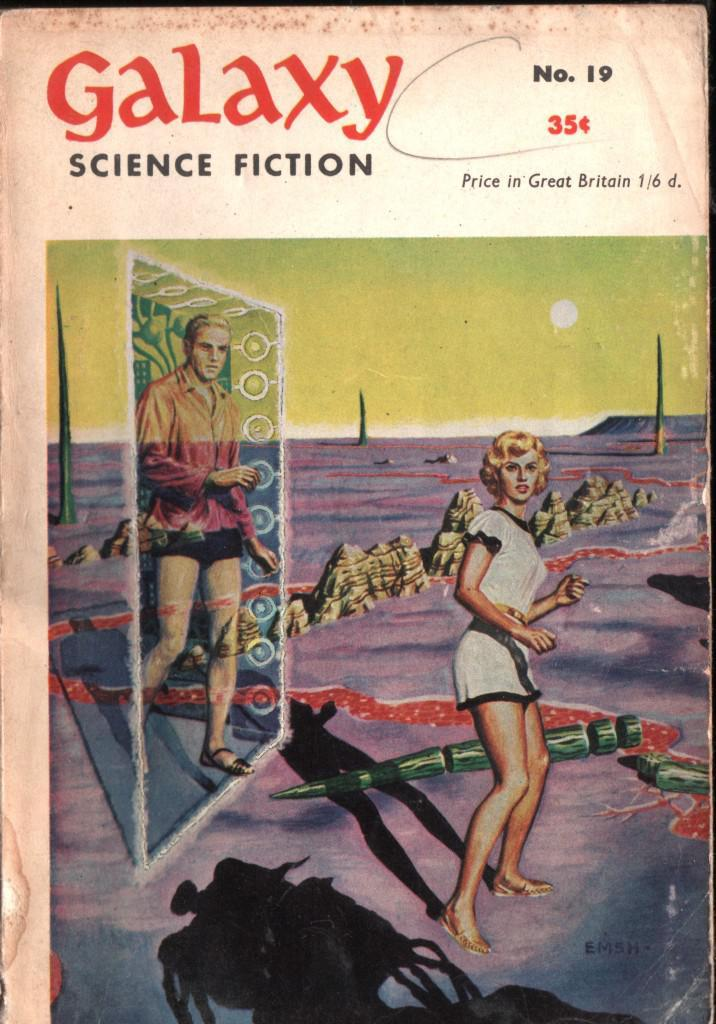What type of characters are present in the cartoon image? There is a cartoon image of a man and a woman in the picture. What celestial object is depicted in the cartoon image? There is a cartoon image of the sun in the picture. What part of the natural environment is included in the cartoon image? The sky is depicted in the cartoon image. Is there any text present in the image? Yes, there is text written on the image. What type of copper material can be seen in the image? There is no copper material present in the image; it is a cartoon image featuring a man, a woman, the sun, the sky, and text. 